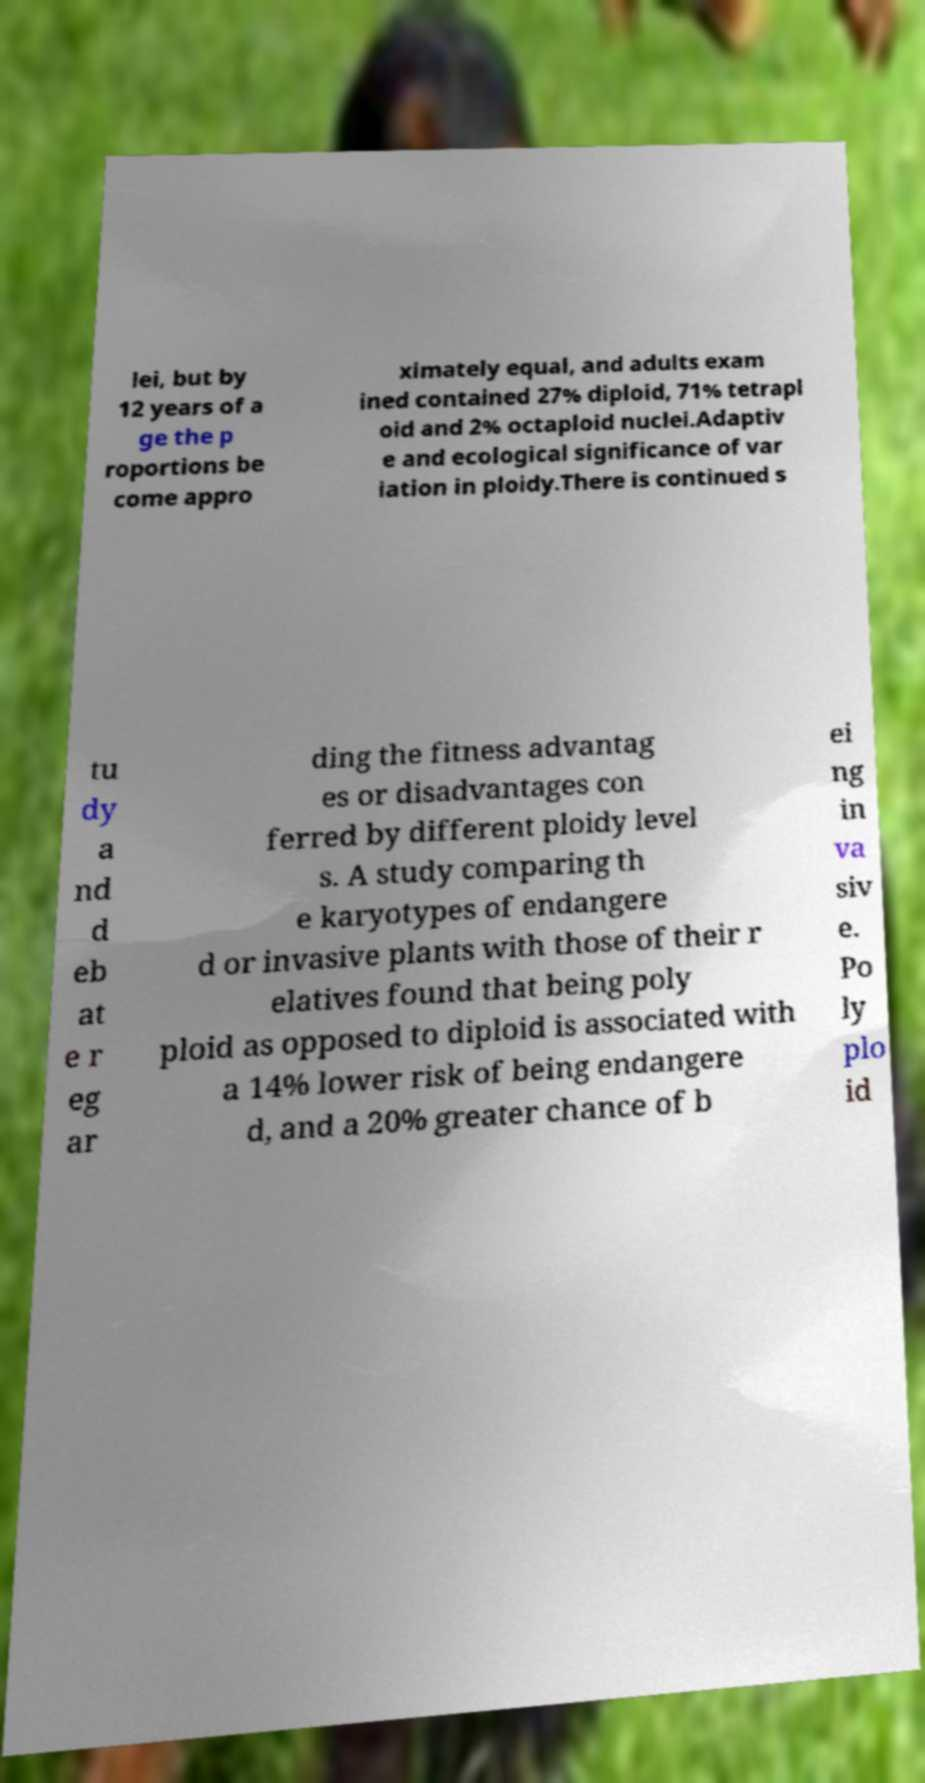What messages or text are displayed in this image? I need them in a readable, typed format. lei, but by 12 years of a ge the p roportions be come appro ximately equal, and adults exam ined contained 27% diploid, 71% tetrapl oid and 2% octaploid nuclei.Adaptiv e and ecological significance of var iation in ploidy.There is continued s tu dy a nd d eb at e r eg ar ding the fitness advantag es or disadvantages con ferred by different ploidy level s. A study comparing th e karyotypes of endangere d or invasive plants with those of their r elatives found that being poly ploid as opposed to diploid is associated with a 14% lower risk of being endangere d, and a 20% greater chance of b ei ng in va siv e. Po ly plo id 